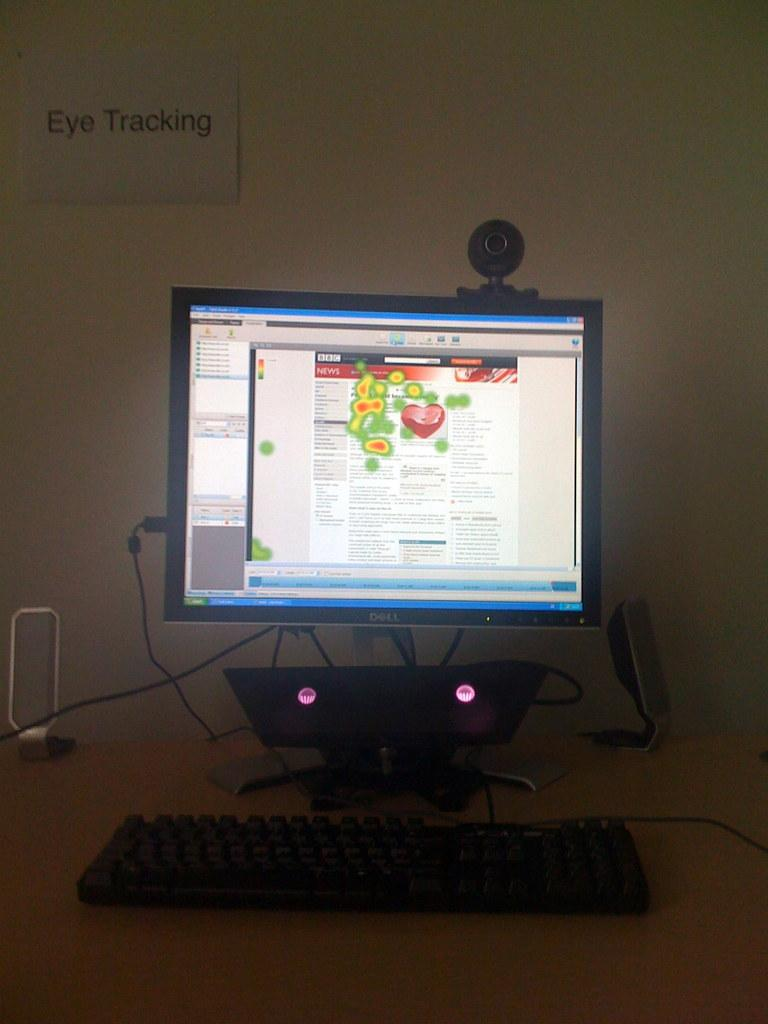Provide a one-sentence caption for the provided image. Eye Tracking reads the sign above the computer monitor. 